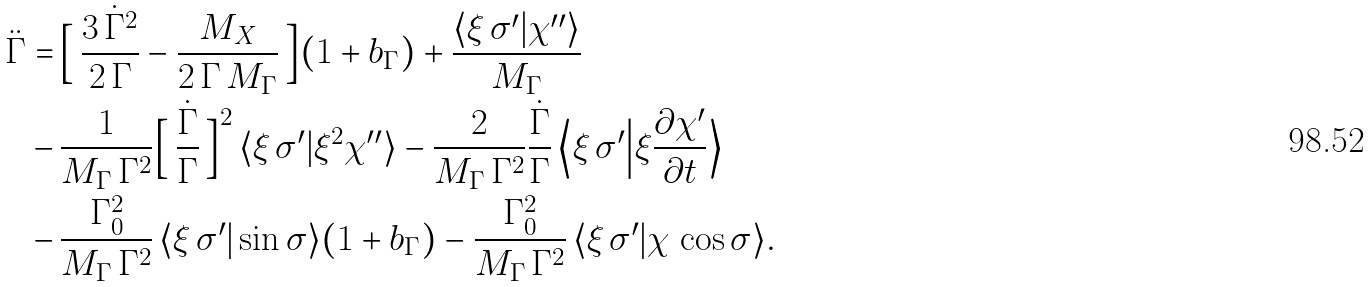Convert formula to latex. <formula><loc_0><loc_0><loc_500><loc_500>\ddot { \Gamma } = & \, \Big [ \, \frac { 3 \, \dot { \Gamma } ^ { 2 } } { 2 \, \Gamma } - \frac { M _ { X } } { 2 \, \Gamma \, M _ { \Gamma } } \, \Big ] ( 1 + b _ { \Gamma } ) + \frac { \langle \xi \, \sigma ^ { \prime } | \chi ^ { \prime \prime } \rangle } { M _ { \Gamma } } \\ - & \, \frac { 1 } { M _ { \Gamma } \, \Gamma ^ { 2 } } \Big [ \, \frac { \dot { \Gamma } } { \Gamma } \, \Big ] ^ { 2 } \, \langle \xi \, \sigma ^ { \prime } | \xi ^ { 2 } \chi ^ { \prime \prime } \rangle - \frac { 2 } { M _ { \Gamma } \, \Gamma ^ { 2 } } \frac { \dot { \Gamma } } { \Gamma } \, \Big \langle \xi \, \sigma ^ { \prime } \Big | \xi \frac { \partial \chi ^ { \prime } } { \partial t } \Big \rangle \\ - & \, \frac { \Gamma _ { 0 } ^ { 2 } } { M _ { \Gamma } \, \Gamma ^ { 2 } } \, \langle \xi \, \sigma ^ { \prime } | \sin \sigma \rangle ( 1 + b _ { \Gamma } ) - \frac { \Gamma _ { 0 } ^ { 2 } } { M _ { \Gamma } \, \Gamma ^ { 2 } } \, \langle \xi \, \sigma ^ { \prime } | \chi \, \cos \sigma \rangle .</formula> 